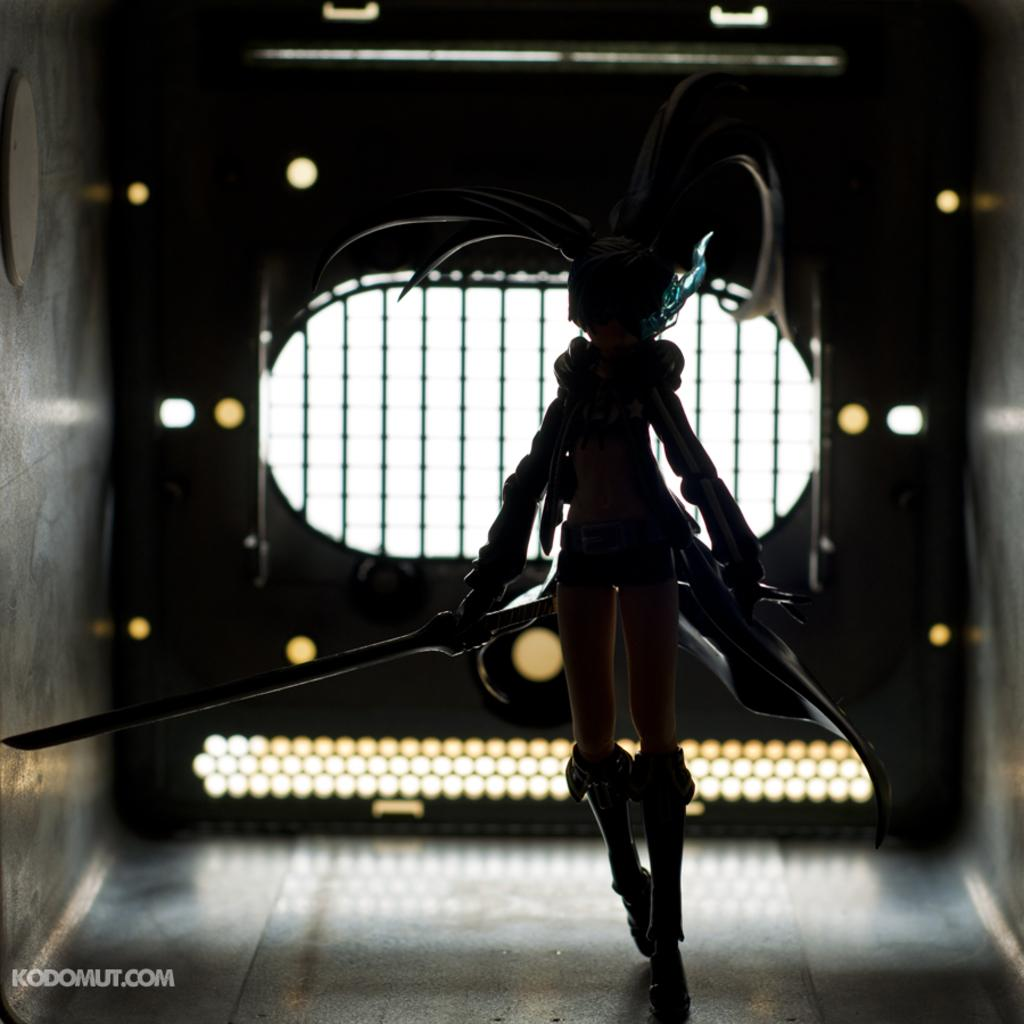What is the person in the image wearing? The person is wearing a costume in the image. What object is the person holding? The person is holding a sword in the image. What can be seen in the background or surrounding area of the image? There are lights and grills visible in the image. What type of teaching is the person in the costume providing to the chickens in the image? There are no chickens present in the image, and the person is not shown teaching anything. 